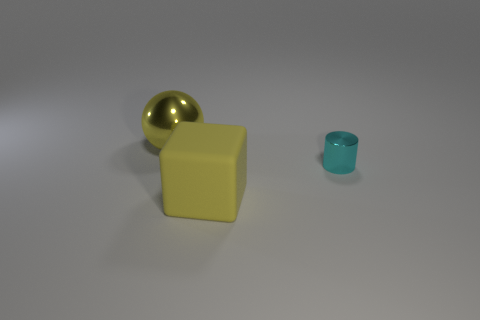Add 2 large yellow rubber cubes. How many objects exist? 5 Subtract all spheres. How many objects are left? 2 Add 3 small objects. How many small objects exist? 4 Subtract 1 cyan cylinders. How many objects are left? 2 Subtract all tiny yellow balls. Subtract all large yellow rubber objects. How many objects are left? 2 Add 1 large yellow metallic objects. How many large yellow metallic objects are left? 2 